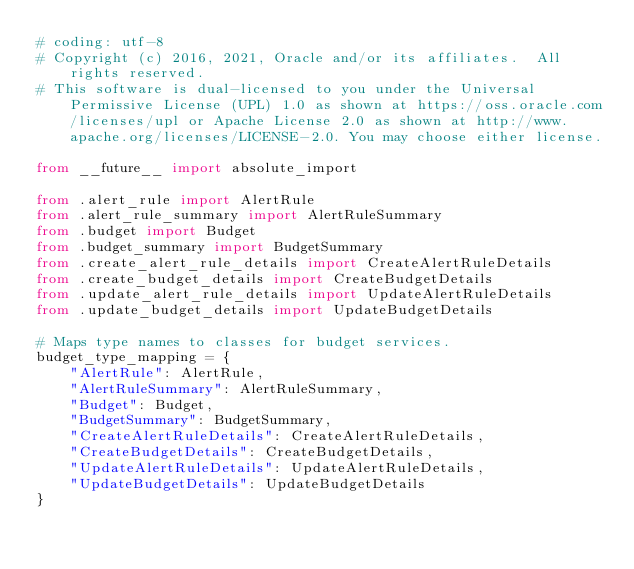Convert code to text. <code><loc_0><loc_0><loc_500><loc_500><_Python_># coding: utf-8
# Copyright (c) 2016, 2021, Oracle and/or its affiliates.  All rights reserved.
# This software is dual-licensed to you under the Universal Permissive License (UPL) 1.0 as shown at https://oss.oracle.com/licenses/upl or Apache License 2.0 as shown at http://www.apache.org/licenses/LICENSE-2.0. You may choose either license.

from __future__ import absolute_import

from .alert_rule import AlertRule
from .alert_rule_summary import AlertRuleSummary
from .budget import Budget
from .budget_summary import BudgetSummary
from .create_alert_rule_details import CreateAlertRuleDetails
from .create_budget_details import CreateBudgetDetails
from .update_alert_rule_details import UpdateAlertRuleDetails
from .update_budget_details import UpdateBudgetDetails

# Maps type names to classes for budget services.
budget_type_mapping = {
    "AlertRule": AlertRule,
    "AlertRuleSummary": AlertRuleSummary,
    "Budget": Budget,
    "BudgetSummary": BudgetSummary,
    "CreateAlertRuleDetails": CreateAlertRuleDetails,
    "CreateBudgetDetails": CreateBudgetDetails,
    "UpdateAlertRuleDetails": UpdateAlertRuleDetails,
    "UpdateBudgetDetails": UpdateBudgetDetails
}
</code> 